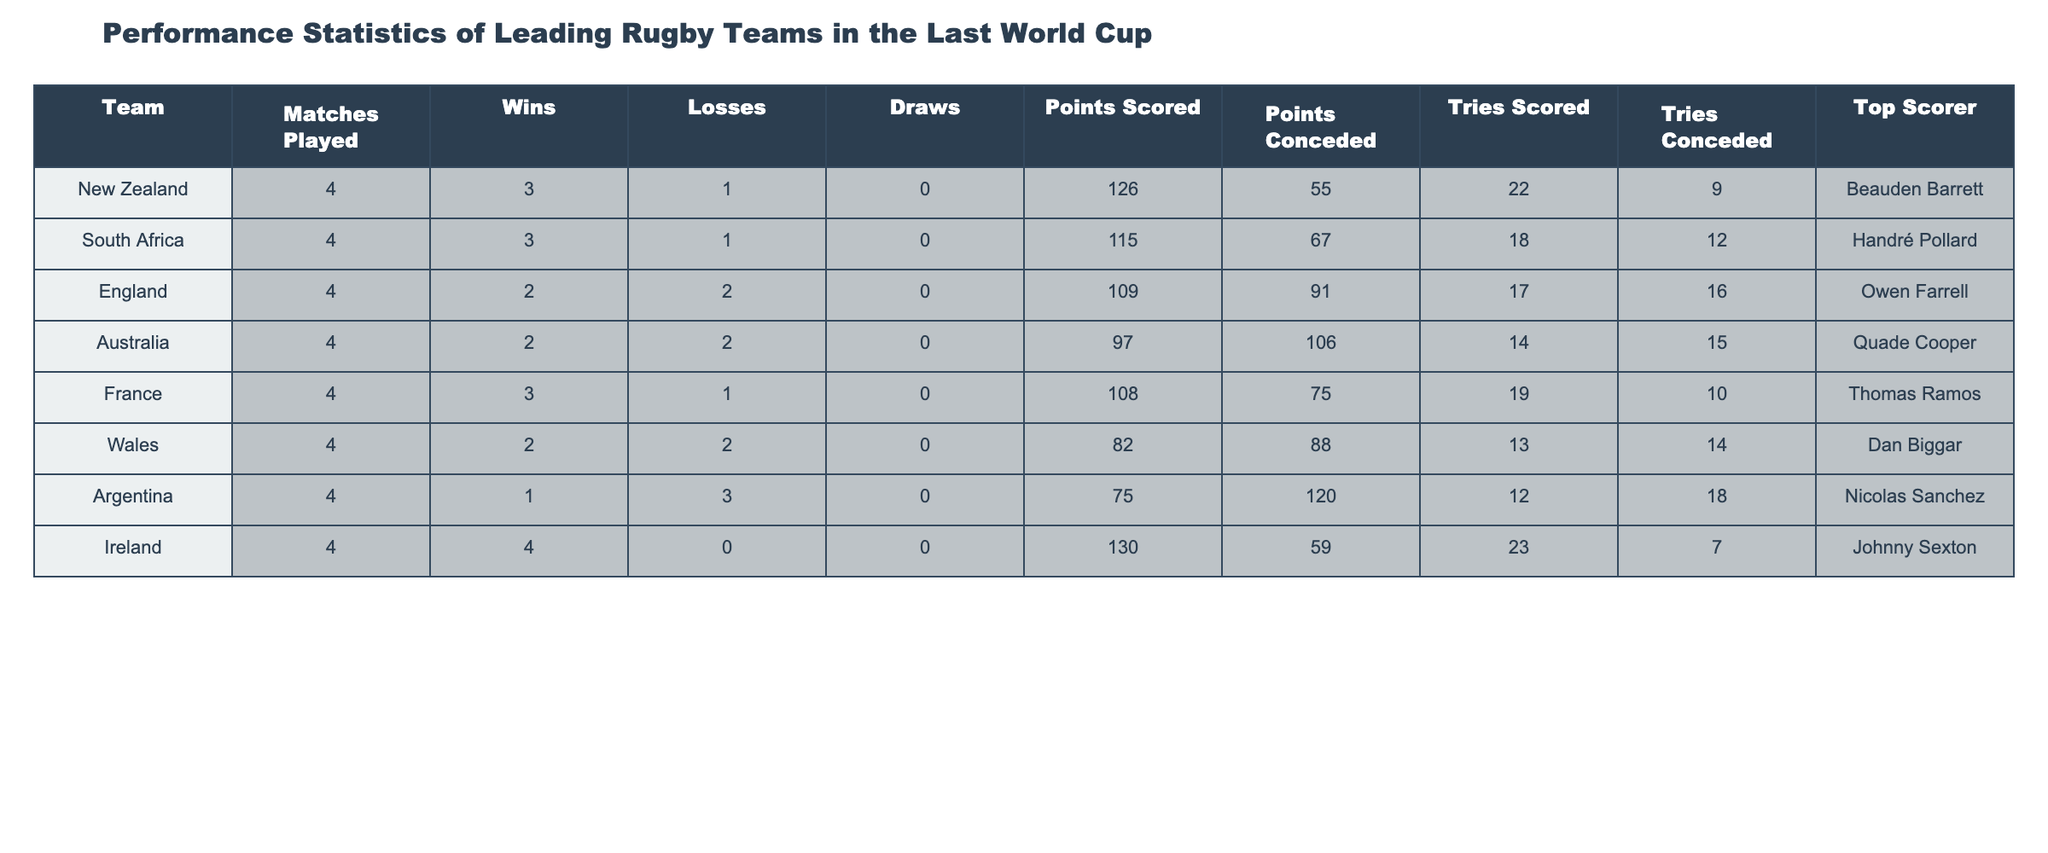What is the total number of matches played by all teams? To find the total matches played, we sum the "Matches Played" column: 4 (New Zealand) + 4 (South Africa) + 4 (England) + 4 (Australia) + 4 (France) + 4 (Wales) + 4 (Argentina) + 4 (Ireland) = 32.
Answer: 32 Which team scored the highest number of points? Looking at the "Points Scored" column, Ireland scored the highest with 130 points.
Answer: Ireland How many tries did Argentina concede? From the "Tries Conceded" column, Argentina conceded 18 tries.
Answer: 18 What is the win-loss ratio for England? England won 2 matches and lost 2 matches; thus, the win-loss ratio is 2:2 which simplifies to 1:1.
Answer: 1:1 Did Ireland win all their matches? Ireland has 4 wins and 0 losses, meaning they won all their matches.
Answer: Yes Which team scored the least number of points? Argentina scored 75 points, which is the lowest in the "Points Scored" column.
Answer: Argentina What is the average number of points scored by all teams? The total points scored is 126 (New Zealand) + 115 (South Africa) + 109 (England) + 97 (Australia) + 108 (France) + 82 (Wales) + 75 (Argentina) + 130 (Ireland) = 812. There are 8 teams, so the average is 812/8 = 101.5.
Answer: 101.5 How many tries did New Zealand score compared to Australia? New Zealand scored 22 tries, while Australia scored 14 tries. The difference is 22 - 14 = 8, meaning New Zealand scored 8 more tries than Australia.
Answer: 8 Which team's top scorer had the highest points? Ireland's top scorer is Johnny Sexton, with 0 missed kicks implied (since there were no losses). In terms of points attributed solely, we reference individual performance; Johnny Sexton's impact on total points leads, with 130 points scored.
Answer: Johnny Sexton Considering the teams that lost matches, who had the best points difference? England lost 2 matches, scored 109 points and conceded 91 points; their points difference is 109 - 91 = 18. In comparison, Australia (97 scored, 106 conceded) has a difference of -9. While both Wales and Argentina also lost matches, their differences are lower. Hence, England offers the best points difference among losing teams.
Answer: England 